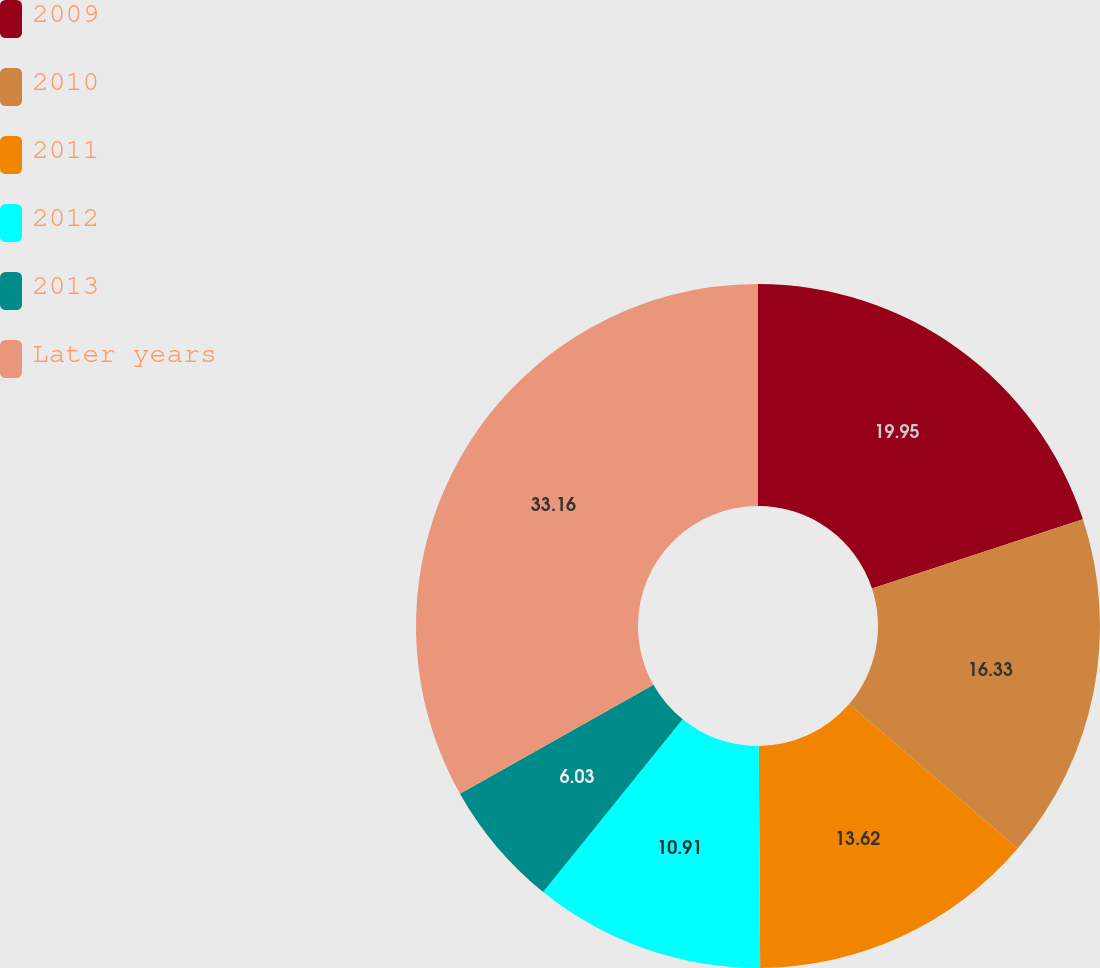<chart> <loc_0><loc_0><loc_500><loc_500><pie_chart><fcel>2009<fcel>2010<fcel>2011<fcel>2012<fcel>2013<fcel>Later years<nl><fcel>19.95%<fcel>16.33%<fcel>13.62%<fcel>10.91%<fcel>6.03%<fcel>33.16%<nl></chart> 